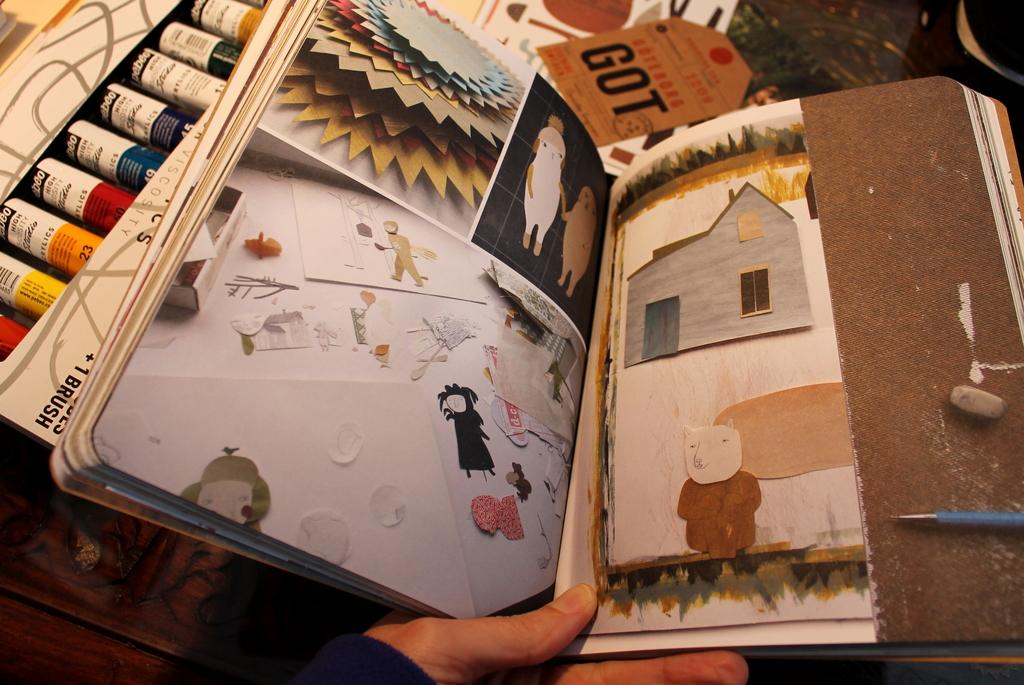<image>
Share a concise interpretation of the image provided. Person looking at a booklet near a tag that says GOT on it. 